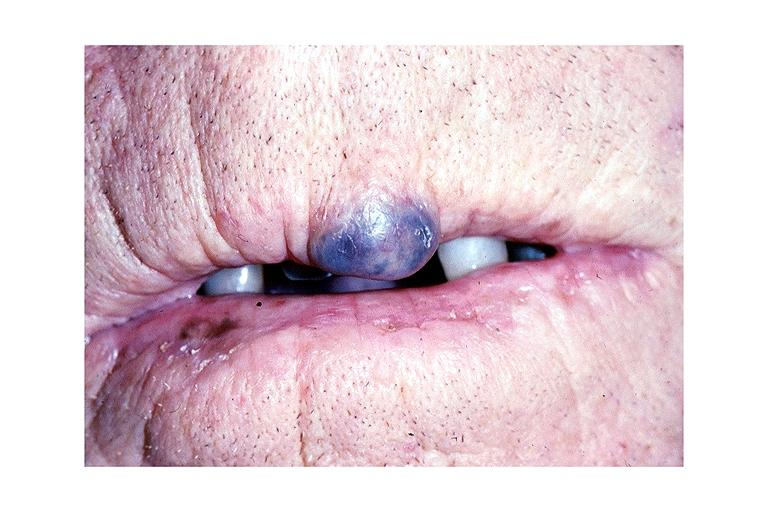where is this?
Answer the question using a single word or phrase. Oral 